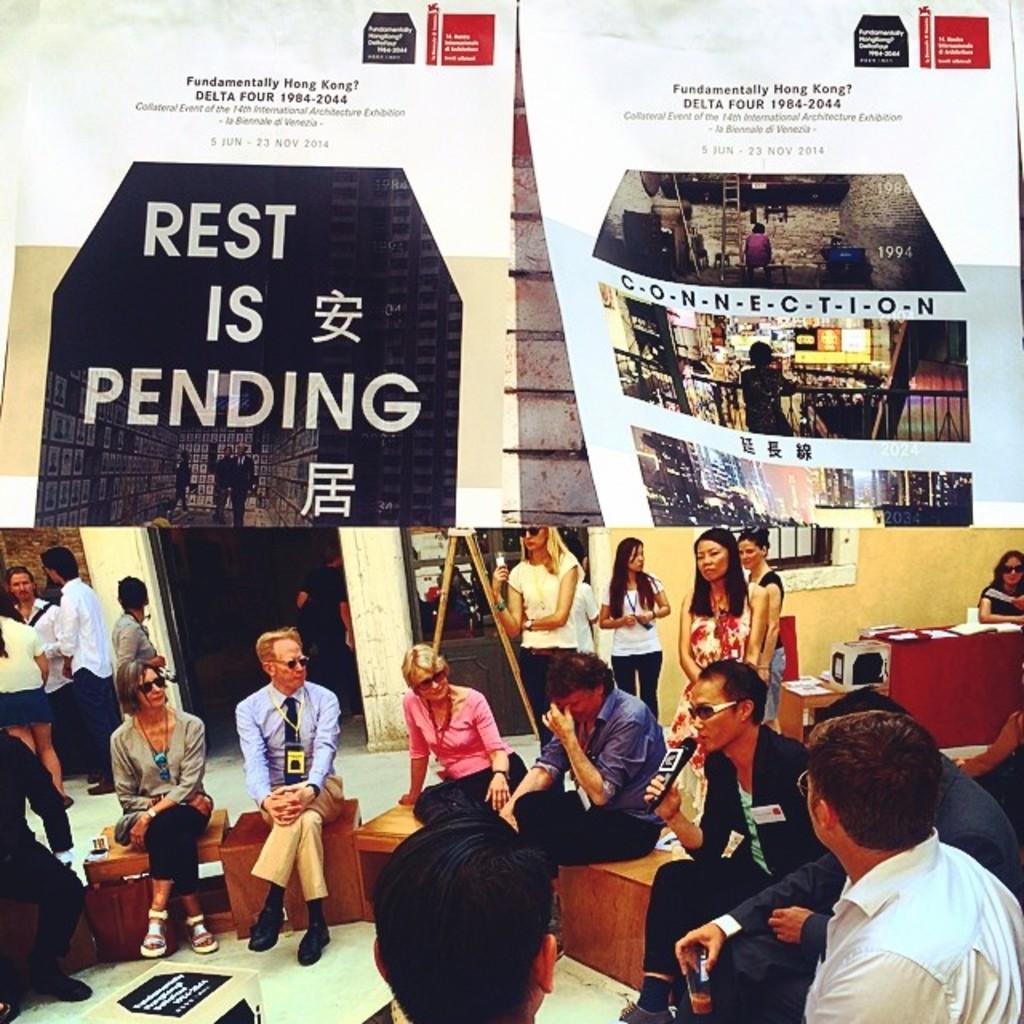Please provide a concise description of this image. In the picture we can see some people are sitting on the stools and some people are standing and on the top of them we can see the banner. 